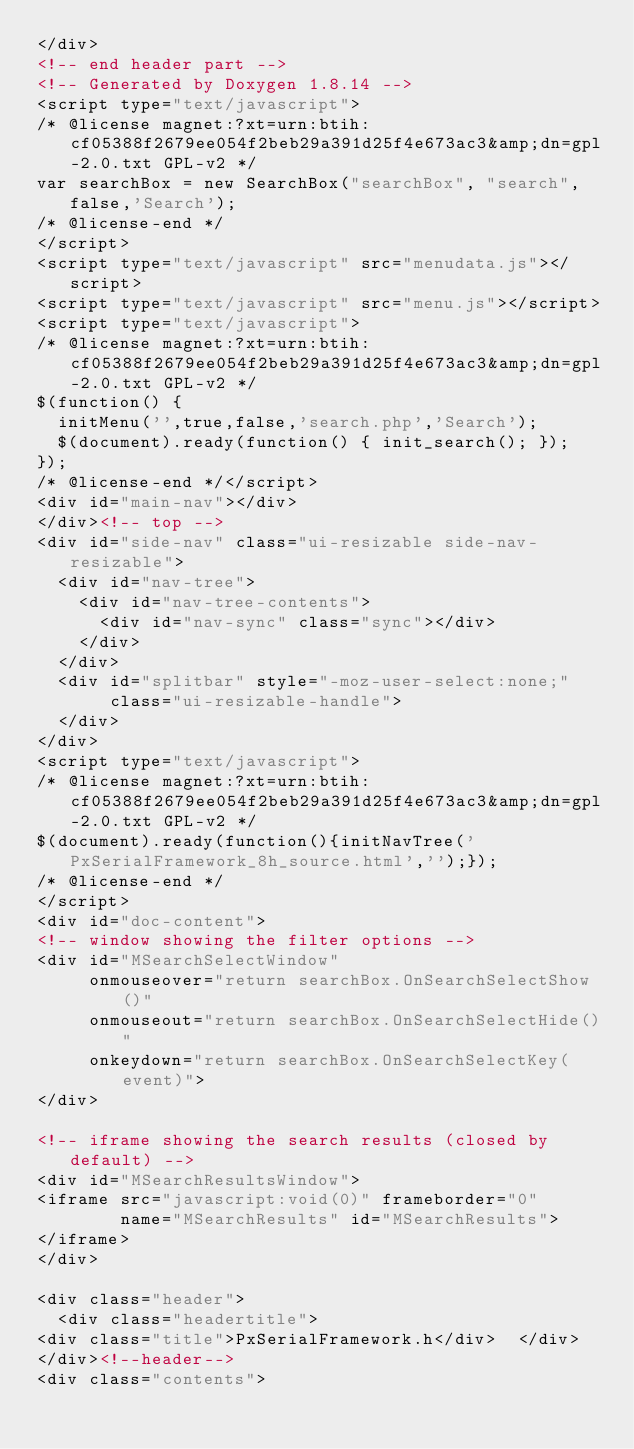Convert code to text. <code><loc_0><loc_0><loc_500><loc_500><_HTML_></div>
<!-- end header part -->
<!-- Generated by Doxygen 1.8.14 -->
<script type="text/javascript">
/* @license magnet:?xt=urn:btih:cf05388f2679ee054f2beb29a391d25f4e673ac3&amp;dn=gpl-2.0.txt GPL-v2 */
var searchBox = new SearchBox("searchBox", "search",false,'Search');
/* @license-end */
</script>
<script type="text/javascript" src="menudata.js"></script>
<script type="text/javascript" src="menu.js"></script>
<script type="text/javascript">
/* @license magnet:?xt=urn:btih:cf05388f2679ee054f2beb29a391d25f4e673ac3&amp;dn=gpl-2.0.txt GPL-v2 */
$(function() {
  initMenu('',true,false,'search.php','Search');
  $(document).ready(function() { init_search(); });
});
/* @license-end */</script>
<div id="main-nav"></div>
</div><!-- top -->
<div id="side-nav" class="ui-resizable side-nav-resizable">
  <div id="nav-tree">
    <div id="nav-tree-contents">
      <div id="nav-sync" class="sync"></div>
    </div>
  </div>
  <div id="splitbar" style="-moz-user-select:none;" 
       class="ui-resizable-handle">
  </div>
</div>
<script type="text/javascript">
/* @license magnet:?xt=urn:btih:cf05388f2679ee054f2beb29a391d25f4e673ac3&amp;dn=gpl-2.0.txt GPL-v2 */
$(document).ready(function(){initNavTree('PxSerialFramework_8h_source.html','');});
/* @license-end */
</script>
<div id="doc-content">
<!-- window showing the filter options -->
<div id="MSearchSelectWindow"
     onmouseover="return searchBox.OnSearchSelectShow()"
     onmouseout="return searchBox.OnSearchSelectHide()"
     onkeydown="return searchBox.OnSearchSelectKey(event)">
</div>

<!-- iframe showing the search results (closed by default) -->
<div id="MSearchResultsWindow">
<iframe src="javascript:void(0)" frameborder="0" 
        name="MSearchResults" id="MSearchResults">
</iframe>
</div>

<div class="header">
  <div class="headertitle">
<div class="title">PxSerialFramework.h</div>  </div>
</div><!--header-->
<div class="contents"></code> 